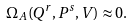Convert formula to latex. <formula><loc_0><loc_0><loc_500><loc_500>\Omega _ { A } ( Q ^ { r } , P ^ { s } , V ) \approx 0 .</formula> 